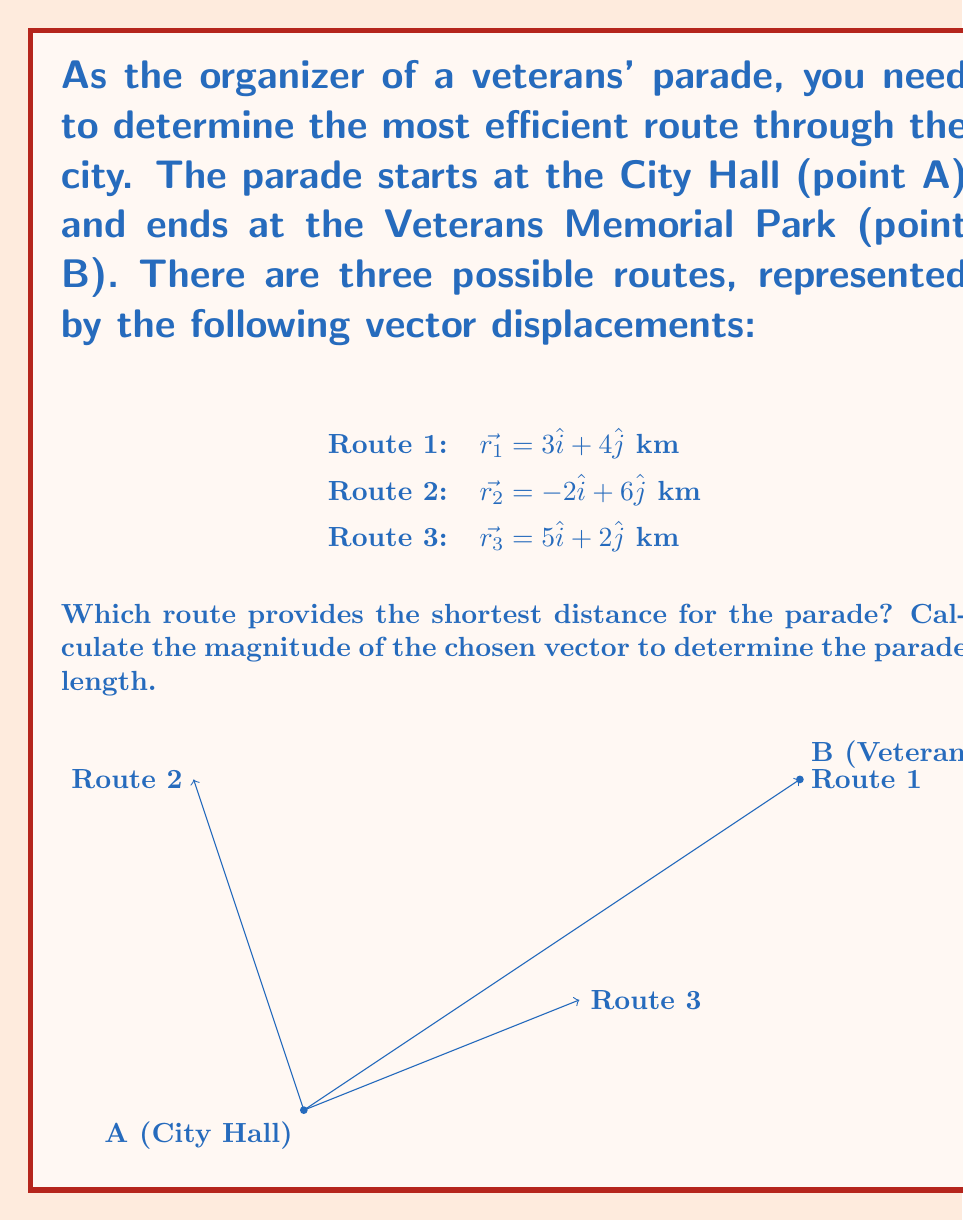Provide a solution to this math problem. To find the most efficient route, we need to calculate the magnitude of each vector displacement and compare them. The magnitude of a vector $\vec{r} = a\hat{i} + b\hat{j}$ is given by the formula:

$$|\vec{r}| = \sqrt{a^2 + b^2}$$

Let's calculate the magnitude of each route:

1. Route 1: $\vec{r_1} = 3\hat{i} + 4\hat{j}$
   $$|\vec{r_1}| = \sqrt{3^2 + 4^2} = \sqrt{9 + 16} = \sqrt{25} = 5$$ km

2. Route 2: $\vec{r_2} = -2\hat{i} + 6\hat{j}$
   $$|\vec{r_2}| = \sqrt{(-2)^2 + 6^2} = \sqrt{4 + 36} = \sqrt{40} = 2\sqrt{10}$$ km

3. Route 3: $\vec{r_3} = 5\hat{i} + 2\hat{j}$
   $$|\vec{r_3}| = \sqrt{5^2 + 2^2} = \sqrt{25 + 4} = \sqrt{29}$$ km

Comparing the magnitudes:
- Route 1: 5 km
- Route 2: $2\sqrt{10} \approx 6.32$ km
- Route 3: $\sqrt{29} \approx 5.39$ km

Route 1 has the smallest magnitude, making it the shortest and most efficient route for the parade.
Answer: Route 1, with a length of 5 km. 